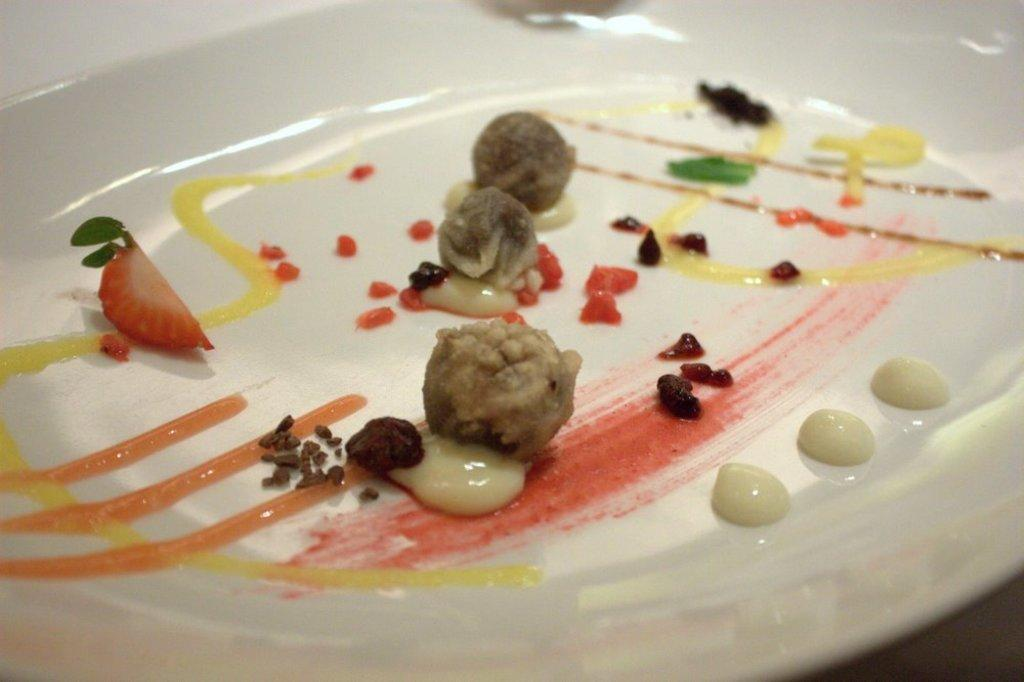What is present on the plate in the image? There is food on the plate in the image. What can be inferred about the plate based on the provided fact? The plate is white in color. How is the food arranged on the plate? Unfortunately, the arrangement of the food on the plate cannot be determined from the given facts. What historical event is depicted in the image? There is no historical event depicted in the image; it features food on a white plate. What is the aftermath of the food in the image? The aftermath of the food cannot be determined from the given facts, as the image only shows the food on a plate. 